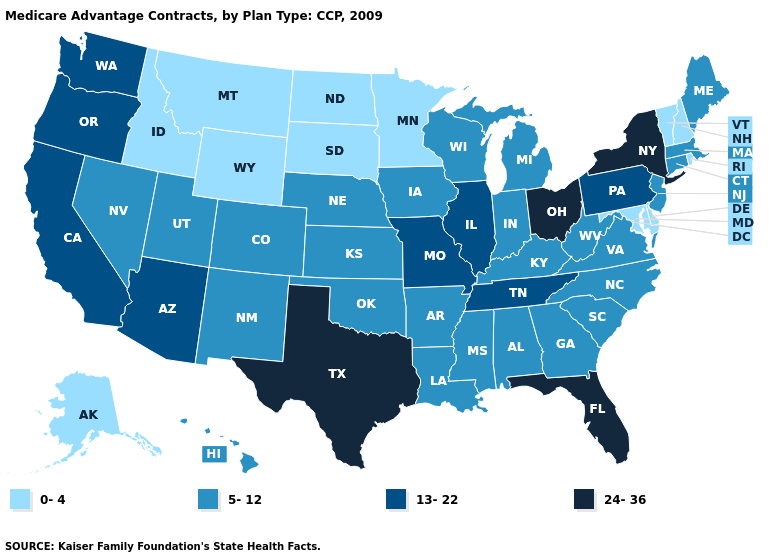Does Florida have the highest value in the South?
Concise answer only. Yes. What is the value of Nevada?
Give a very brief answer. 5-12. What is the value of New Jersey?
Write a very short answer. 5-12. Among the states that border Idaho , which have the lowest value?
Keep it brief. Montana, Wyoming. Name the states that have a value in the range 5-12?
Be succinct. Alabama, Arkansas, Colorado, Connecticut, Georgia, Hawaii, Iowa, Indiana, Kansas, Kentucky, Louisiana, Massachusetts, Maine, Michigan, Mississippi, North Carolina, Nebraska, New Jersey, New Mexico, Nevada, Oklahoma, South Carolina, Utah, Virginia, Wisconsin, West Virginia. Which states have the highest value in the USA?
Short answer required. Florida, New York, Ohio, Texas. What is the highest value in states that border Wyoming?
Concise answer only. 5-12. How many symbols are there in the legend?
Keep it brief. 4. Does New Hampshire have the same value as Washington?
Be succinct. No. Among the states that border Washington , does Idaho have the highest value?
Be succinct. No. Which states have the lowest value in the West?
Write a very short answer. Alaska, Idaho, Montana, Wyoming. What is the highest value in the USA?
Be succinct. 24-36. What is the value of Maryland?
Quick response, please. 0-4. What is the value of Oregon?
Write a very short answer. 13-22. Does Wyoming have the lowest value in the USA?
Answer briefly. Yes. 